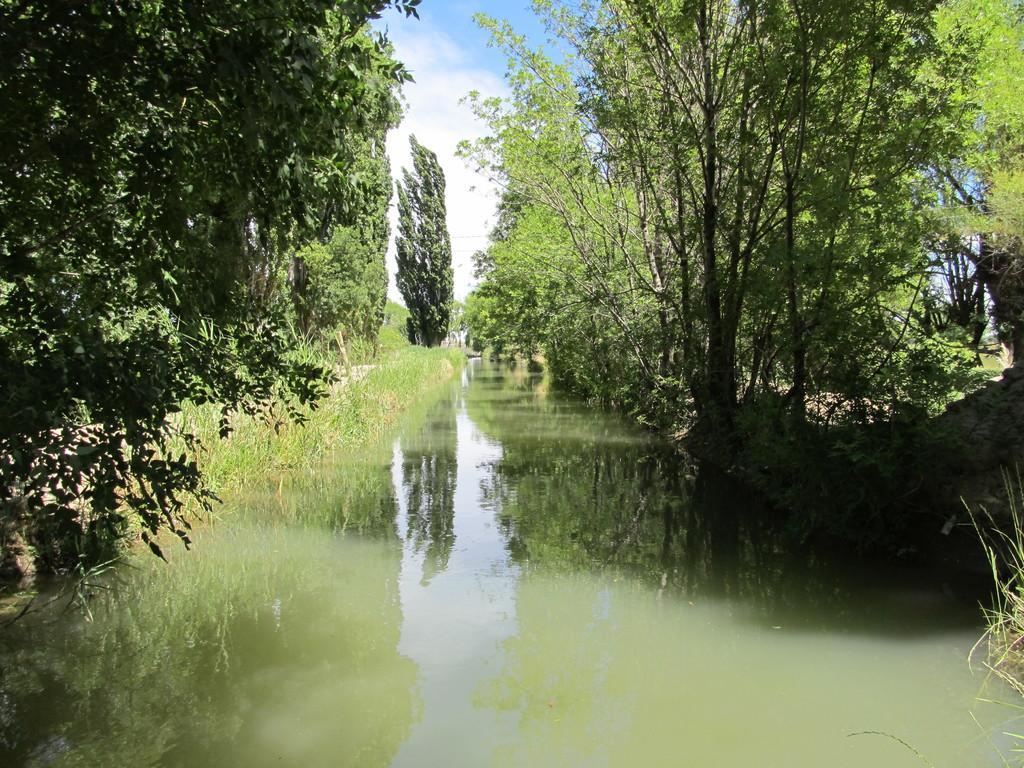How would you summarize this image in a sentence or two? This picture is clicked outside the city. In the center there is a water body. On the right and on the left we can see the trees. In the background there is a sky. 